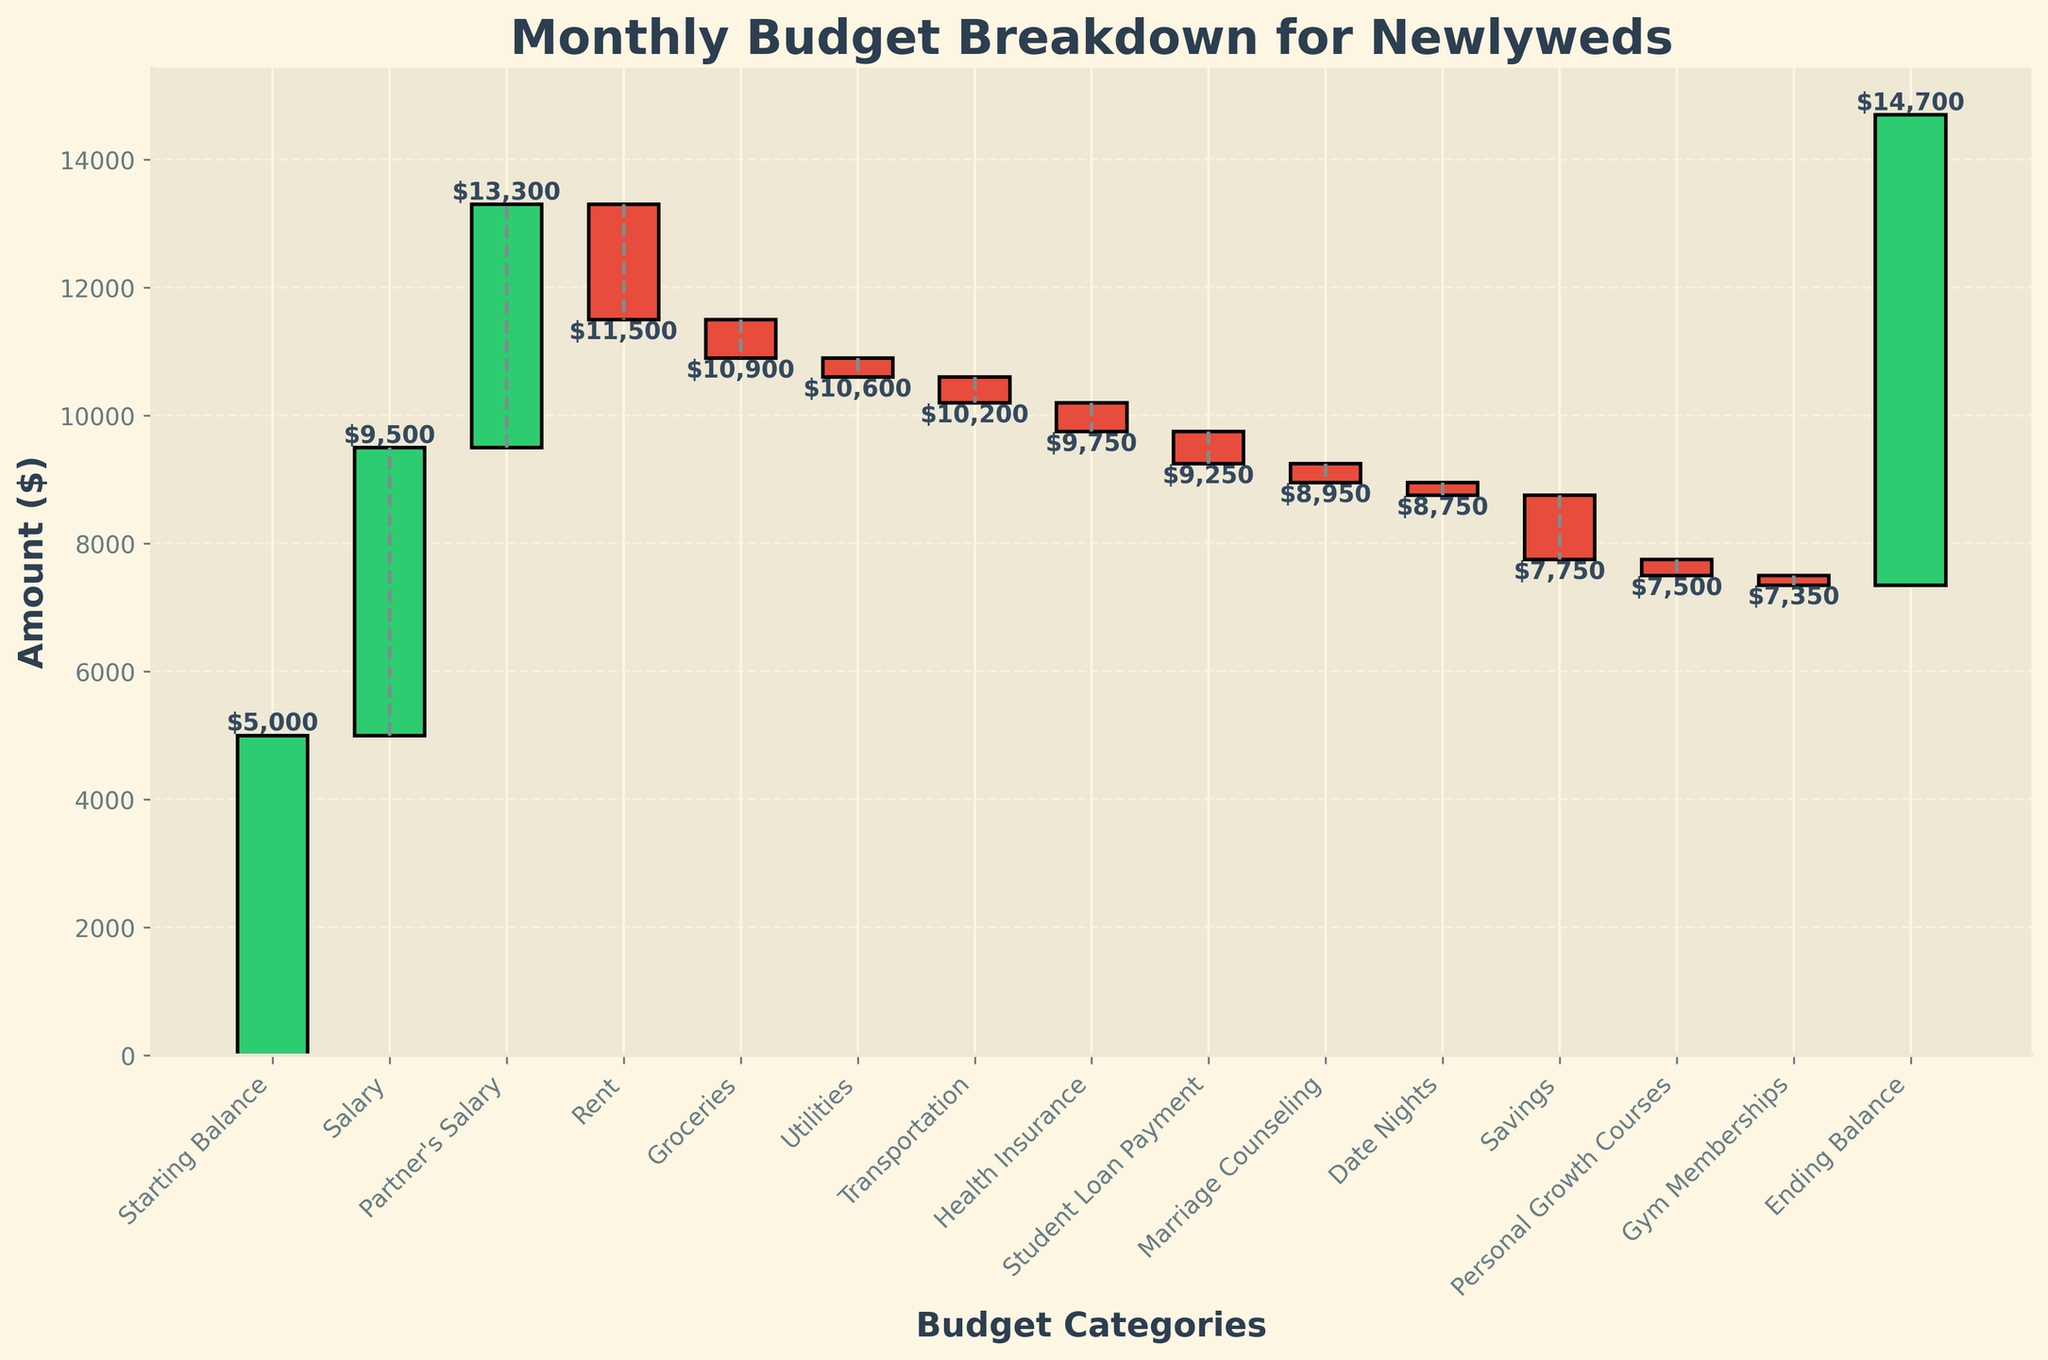How much is the Starting Balance? The Starting Balance is the initial amount shown in the figure.
Answer: $5000 What is the highest expense category, and how much was it? To find the highest expense category, look for the category with the largest negative amount.
Answer: Rent, -$1800 How do the cumulative amounts change after Salaries are added? To find the change, sum the Starting Balance and both Salary categories, then plot the cumulative amount on the y-axis.
Answer: $13300 What is the cumulative amount after Marriage Counseling? Gather all amounts up to and including Marriage Counseling, then sum them to find the cumulative total.
Answer: $9350 How does the category 'Savings' affect the balance? The Savings category should be deducted from the preceding cumulative amount to show its effect on the Ending Balance.
Answer: It decreases the balance by $1000 Which expense category directly precedes the 'Ending Balance,' and by how much does it increase the balance? Review the last two entries before Ending Balance to find the preceding category and its effect. Personal Growth Courses precede Gym Membership, then Ending Balance.
Answer: Gym Membership, affects by increasing $7350 from the chosen category Compare the amounts of Groceries and Transportation. Which one is higher? To compare these categories, look at their respective values in the figure and identify the higher amount.
Answer: Groceries, -$600 What is the net effect of all expenses compared to the initial Starting Balance? Calculate the sum of all expenses and subtract it from the Starting Balance to determine the net effect.
Answer: Net effect decreases by $1450 By how much does the Ending Balance exceed the Starting Balance? Take the Ending Balance amount and subtract the Starting Balance from it to determine the difference.
Answer: $2350 How many categories contribute positively to the balance, and what are they? Count the number of categories with positive amounts and list them. These are non-expense categories.
Answer: Three Categories: Salary, Partner's Salary, and Ending Balance 